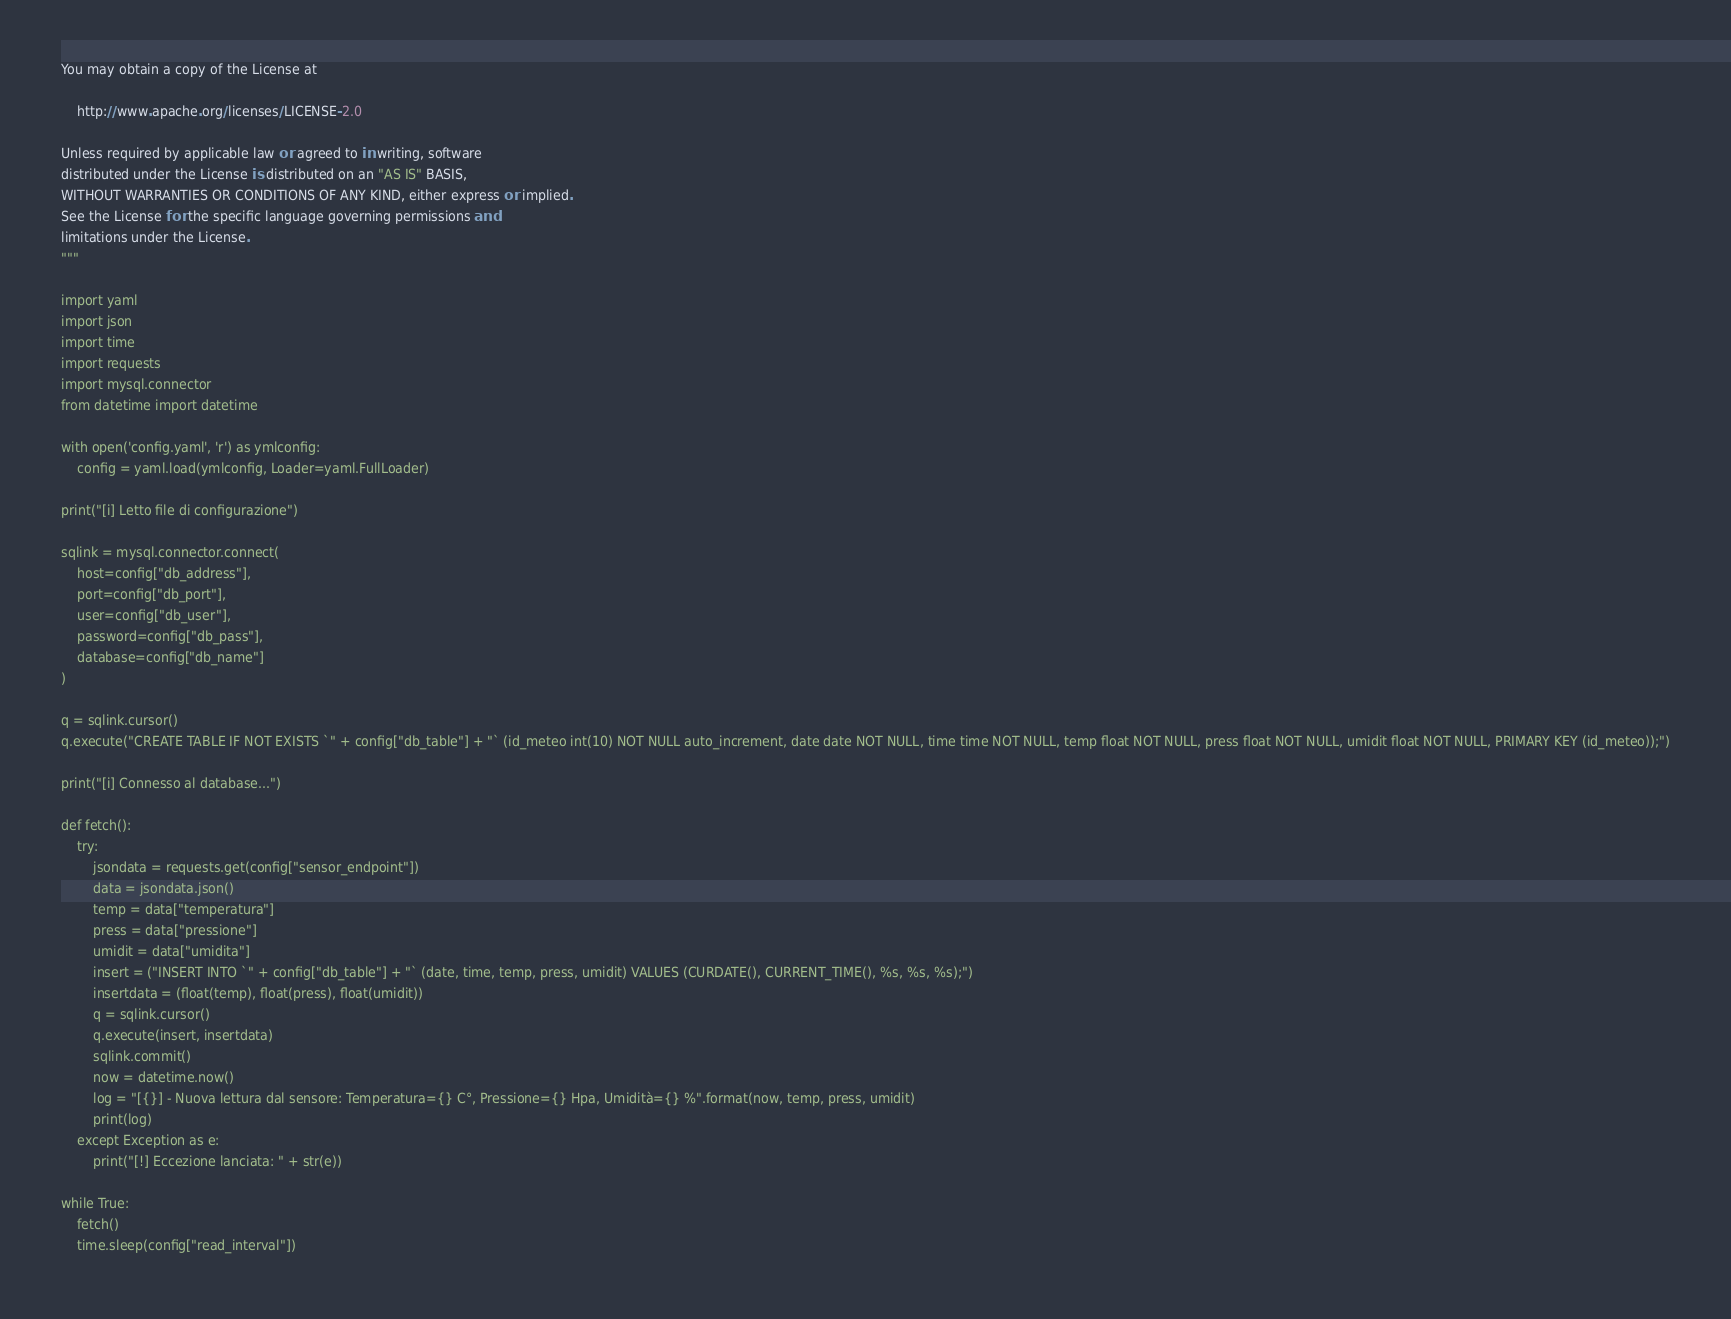Convert code to text. <code><loc_0><loc_0><loc_500><loc_500><_Python_>You may obtain a copy of the License at

    http://www.apache.org/licenses/LICENSE-2.0

Unless required by applicable law or agreed to in writing, software
distributed under the License is distributed on an "AS IS" BASIS,
WITHOUT WARRANTIES OR CONDITIONS OF ANY KIND, either express or implied.
See the License for the specific language governing permissions and
limitations under the License. 
"""

import yaml
import json
import time
import requests
import mysql.connector
from datetime import datetime

with open('config.yaml', 'r') as ymlconfig:
    config = yaml.load(ymlconfig, Loader=yaml.FullLoader)

print("[i] Letto file di configurazione")

sqlink = mysql.connector.connect(
    host=config["db_address"],
    port=config["db_port"],
    user=config["db_user"],
    password=config["db_pass"],
    database=config["db_name"]
)

q = sqlink.cursor()
q.execute("CREATE TABLE IF NOT EXISTS `" + config["db_table"] + "` (id_meteo int(10) NOT NULL auto_increment, date date NOT NULL, time time NOT NULL, temp float NOT NULL, press float NOT NULL, umidit float NOT NULL, PRIMARY KEY (id_meteo));")

print("[i] Connesso al database...")

def fetch(): 
    try:
        jsondata = requests.get(config["sensor_endpoint"])
        data = jsondata.json()
        temp = data["temperatura"]
        press = data["pressione"]
        umidit = data["umidita"]
        insert = ("INSERT INTO `" + config["db_table"] + "` (date, time, temp, press, umidit) VALUES (CURDATE(), CURRENT_TIME(), %s, %s, %s);")
        insertdata = (float(temp), float(press), float(umidit))
        q = sqlink.cursor()
        q.execute(insert, insertdata)
        sqlink.commit()
        now = datetime.now()
        log = "[{}] - Nuova lettura dal sensore: Temperatura={} C°, Pressione={} Hpa, Umidità={} %".format(now, temp, press, umidit)
        print(log)
    except Exception as e:
        print("[!] Eccezione lanciata: " + str(e))

while True:
    fetch()
    time.sleep(config["read_interval"])</code> 